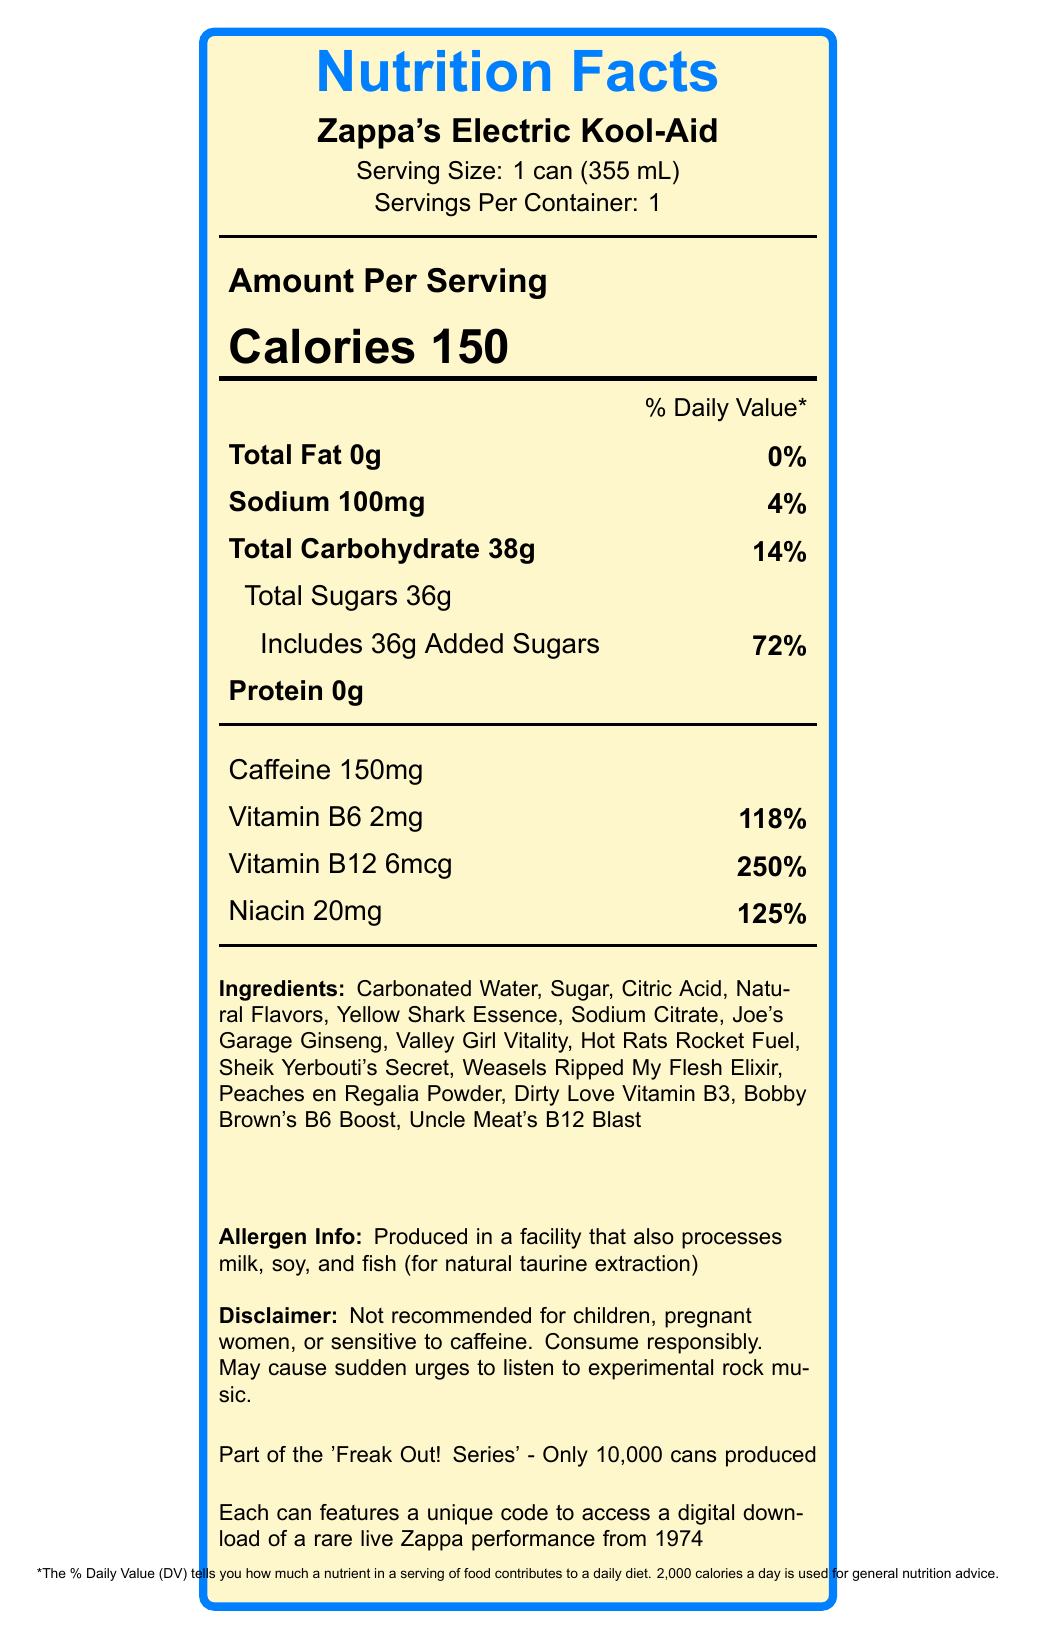what is the serving size? The serving size is clearly listed as "1 can (355 mL)" on the label.
Answer: 1 can (355 mL) how many calories are in one serving? The label indicates that there are 150 calories per serving.
Answer: 150 what percentage of the daily value is the total fat? The label states "Total Fat 0g" and the daily value is listed as "0%".
Answer: 0% what are the quirky ingredient names associated with caffeine? The ingredient list indicates that "Caffeine" has the quirky name "Hot Rats Rocket Fuel".
Answer: Hot Rats Rocket Fuel how much sodium is in a serving? The sodium content is listed as "100mg" on the label.
Answer: 100mg which vitamin has the highest daily value percentage? A. Vitamin B6 B. Vitamin B12 C. Niacin D. Sodium Vitamin B12 has the highest daily value at 250%, as indicated on the label.
Answer: B which of the following ingredients is not listed on the can? A. Carbonated Water B. Aspartame C. Sodium Citrate D. Sugar Aspartame is not listed among the ingredients on the label.
Answer: B is this product recommended for children? The disclaimer explicitly states, "Not recommended for children."
Answer: No summarize the main idea of this document. The document provides comprehensive nutritional information, ingredient details with quirky names, a disclaimer about consumption, and unique marketing points related to limited production and vinyl collector bonuses.
Answer: This document is a Nutrition Facts Label for a limited edition energy drink called "Zappa's Electric Kool-Aid," part of the 'Freak Out! Series'. It provides details on serving size, calorie count, nutritional content, ingredients (with quirky names), allergen information, and a disclaimer about its recommended consumers. Additionally, it offers a bonus feature for vinyl collectors. what is the source of natural taurine in the allergen information? The allergen information notes that the product is processed in a facility that also processes fish for natural taurine extraction.
Answer: fish how many grams of added sugars does this product contain? The label specifies that there are "36g" of added sugars.
Answer: 36g what time period is the rare live Zappa performance from? The label states that the digital download code offers access to a rare live Zappa performance from 1974.
Answer: 1974 what is the quirky name for niacinamide? The label lists "Dirty Love Vitamin B3" as the quirky name for niacinamide.
Answer: Dirty Love Vitamin B3 how many servings are in the container? The label indicates that there is "1" serving per container.
Answer: 1 how much protein does one serving contain? The label lists "Protein 0g".
Answer: 0g what is the percentage of daily value for added sugars? The label specifies that the "Includes 36g Added Sugars" and the daily value percentage is "72%".
Answer: 72% which ingredient is referred to as "Peaches en Regalia Powder"? The quirky ingredient name for Guarana Seed Extract is "Peaches en Regalia Powder".
Answer: Guarana Seed Extract what is the total carbohydrate content in one serving? what is the percentage of daily value? The label states that the "Total Carbohydrate" content is "38g" and the daily value percentage is "14%".
Answer: 38g, 14% what is the amount of caffeine in one serving? The label lists "Caffeine 150mg".
Answer: 150mg what is Uncle Meat's B12 Blast? The ingredient list indicates that "Cyanocobalamin" has the quirky name "Uncle Meat's B12 Blast".
Answer: Cyanocobalamin how many versions of this limited edition product were produced? The label states that only "10,000 cans" were produced.
Answer: 10,000 what is the facility of production recommended for consumers with milk and soy allergies? The label indicates that the product is "Produced in a facility that also processes milk and soy," implying it may not be safe for those with these allergies.
Answer: No is pyridoxine hydrochloride safe for children? The disclaimer notes that the product, including its ingredients like pyridoxine hydrochloride, is "Not recommended for children."
Answer: Not recommended for children what is the total sugar content? The total sugar content is given as 36g, but without further breakdown it cannot be determined if this includes both natural and added sugars or just added sugars.
Answer: Cannot be determined For what is Yellow Shark Essence a quirky name? The document lists "Yellow Shark Essence" as the quirky name for "Taurine".
Answer: Taurine 